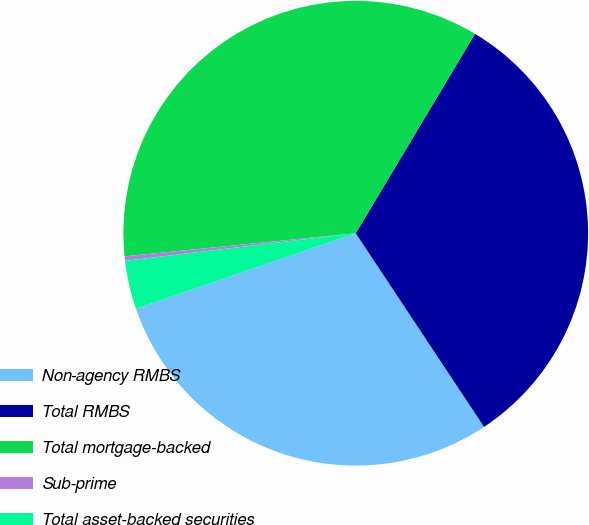Convert chart. <chart><loc_0><loc_0><loc_500><loc_500><pie_chart><fcel>Non-agency RMBS<fcel>Total RMBS<fcel>Total mortgage-backed<fcel>Sub-prime<fcel>Total asset-backed securities<nl><fcel>29.05%<fcel>32.11%<fcel>35.17%<fcel>0.31%<fcel>3.37%<nl></chart> 